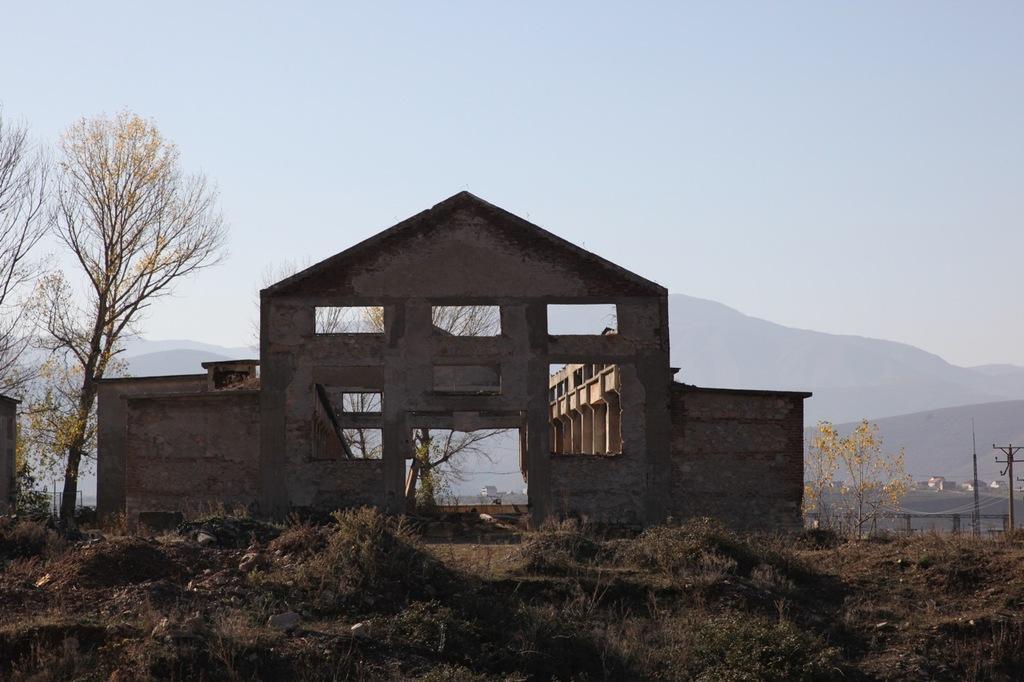Describe this image in one or two sentences. In the image we can see there is a building and there is a ground which is covered with dry grass. Behind there are trees. 